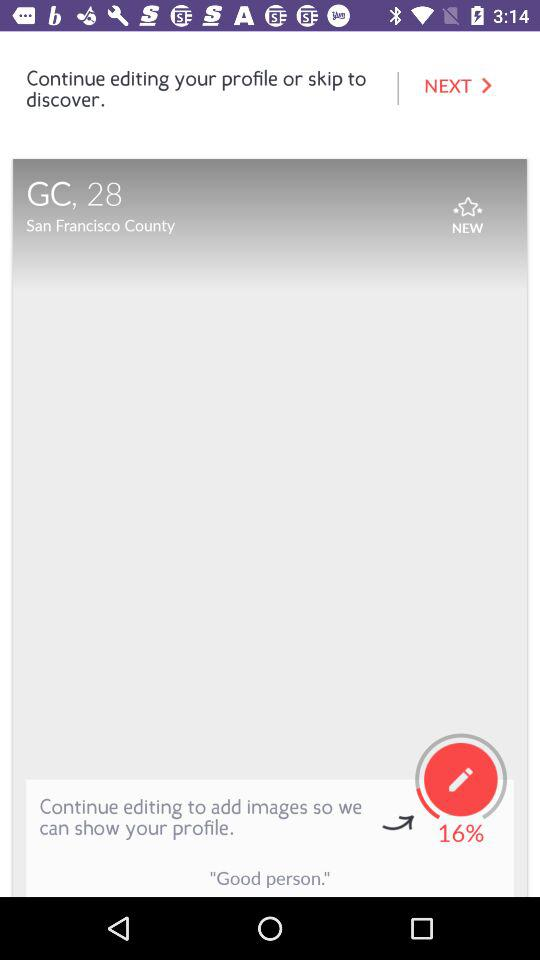How many percent of the way are you to completing your profile?
Answer the question using a single word or phrase. 16% 